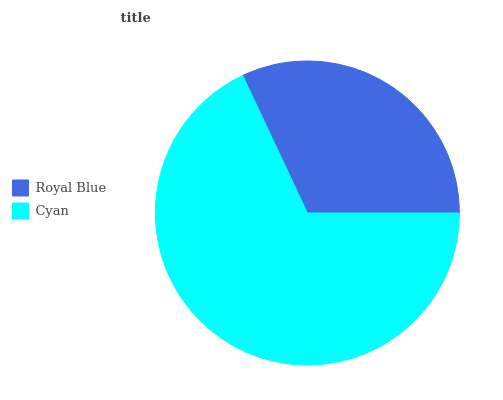Is Royal Blue the minimum?
Answer yes or no. Yes. Is Cyan the maximum?
Answer yes or no. Yes. Is Cyan the minimum?
Answer yes or no. No. Is Cyan greater than Royal Blue?
Answer yes or no. Yes. Is Royal Blue less than Cyan?
Answer yes or no. Yes. Is Royal Blue greater than Cyan?
Answer yes or no. No. Is Cyan less than Royal Blue?
Answer yes or no. No. Is Cyan the high median?
Answer yes or no. Yes. Is Royal Blue the low median?
Answer yes or no. Yes. Is Royal Blue the high median?
Answer yes or no. No. Is Cyan the low median?
Answer yes or no. No. 